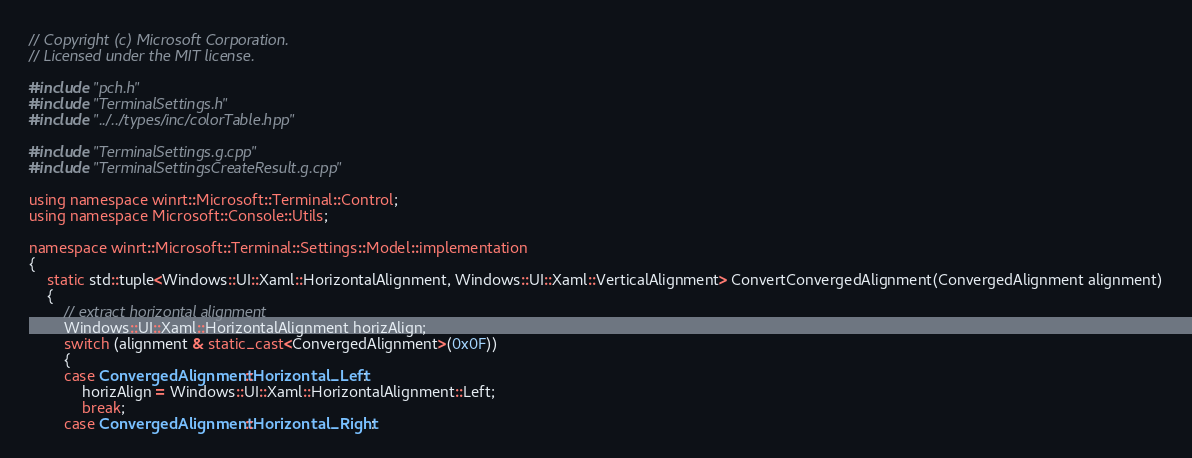<code> <loc_0><loc_0><loc_500><loc_500><_C++_>// Copyright (c) Microsoft Corporation.
// Licensed under the MIT license.

#include "pch.h"
#include "TerminalSettings.h"
#include "../../types/inc/colorTable.hpp"

#include "TerminalSettings.g.cpp"
#include "TerminalSettingsCreateResult.g.cpp"

using namespace winrt::Microsoft::Terminal::Control;
using namespace Microsoft::Console::Utils;

namespace winrt::Microsoft::Terminal::Settings::Model::implementation
{
    static std::tuple<Windows::UI::Xaml::HorizontalAlignment, Windows::UI::Xaml::VerticalAlignment> ConvertConvergedAlignment(ConvergedAlignment alignment)
    {
        // extract horizontal alignment
        Windows::UI::Xaml::HorizontalAlignment horizAlign;
        switch (alignment & static_cast<ConvergedAlignment>(0x0F))
        {
        case ConvergedAlignment::Horizontal_Left:
            horizAlign = Windows::UI::Xaml::HorizontalAlignment::Left;
            break;
        case ConvergedAlignment::Horizontal_Right:</code> 